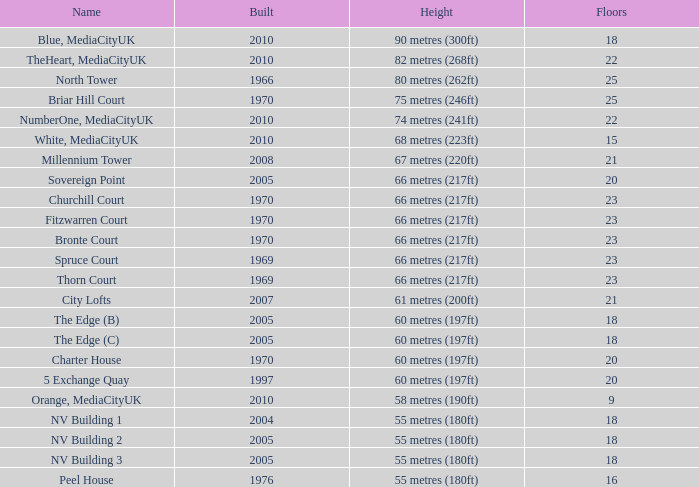What is the altitude, when rating is below 20, when storeys is more than 9, when established is 2005, and when moniker is the edge (c)? 60 metres (197ft). 